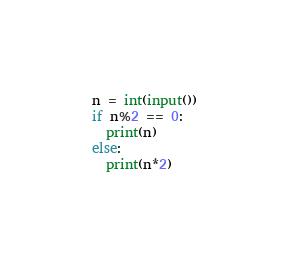Convert code to text. <code><loc_0><loc_0><loc_500><loc_500><_Python_>n = int(input())
if n%2 == 0:
  print(n)
else:
  print(n*2)</code> 